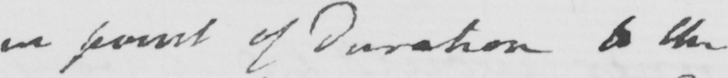What text is written in this handwritten line? in point of duration to the 